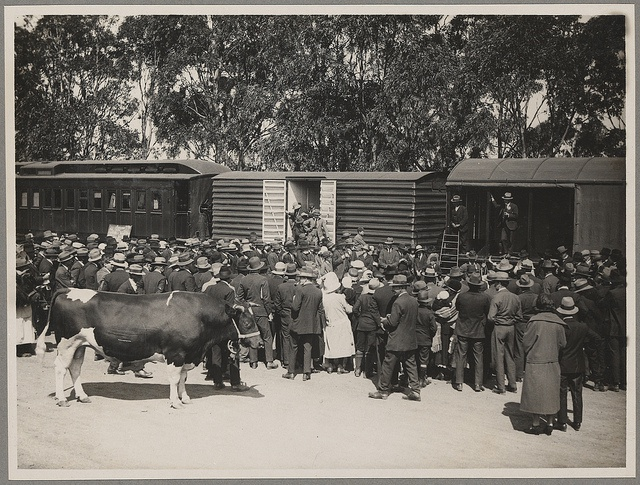Describe the objects in this image and their specific colors. I can see train in gray, black, and darkgray tones, cow in gray, black, darkgray, and lightgray tones, people in gray and black tones, people in gray, black, and darkgray tones, and people in gray, black, and darkgray tones in this image. 